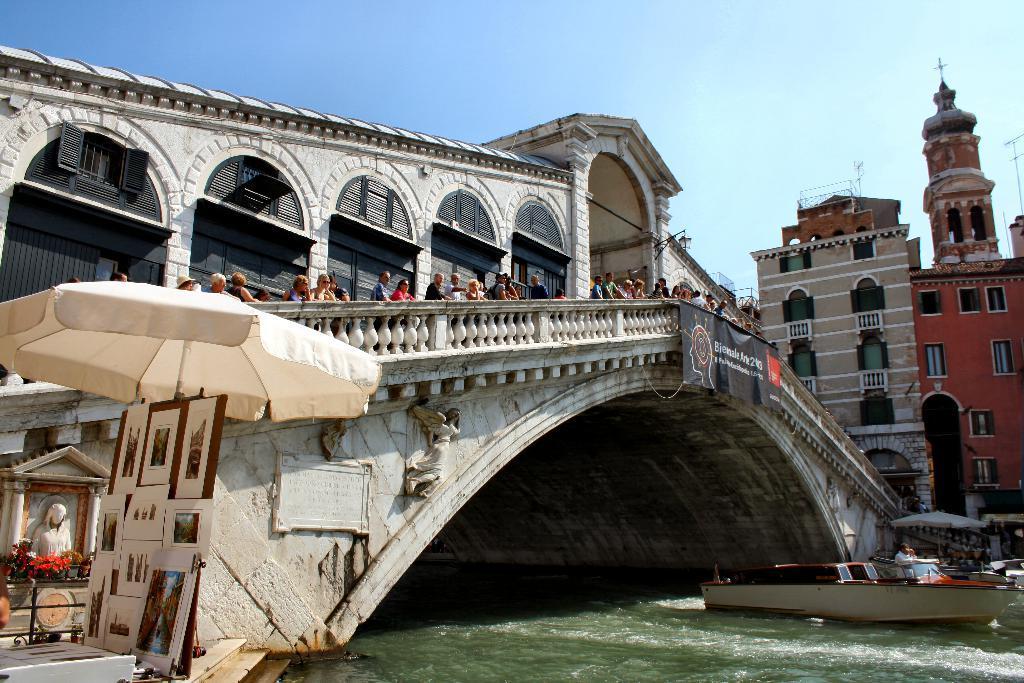In one or two sentences, can you explain what this image depicts? In this image there are buildings, bridge, banner, boards, pictures, boat, umbrellas, statue, people, water, sky and objects. Something is written on the banner.   